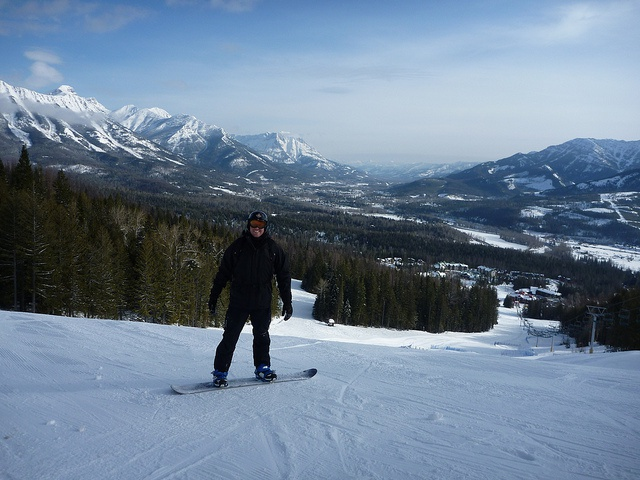Describe the objects in this image and their specific colors. I can see people in gray, black, navy, and darkgray tones and snowboard in gray and darkgray tones in this image. 